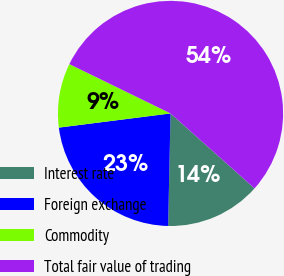Convert chart to OTSL. <chart><loc_0><loc_0><loc_500><loc_500><pie_chart><fcel>Interest rate<fcel>Foreign exchange<fcel>Commodity<fcel>Total fair value of trading<nl><fcel>13.74%<fcel>22.65%<fcel>9.23%<fcel>54.37%<nl></chart> 